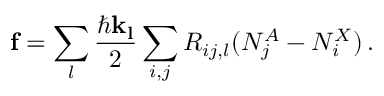<formula> <loc_0><loc_0><loc_500><loc_500>f = \sum _ { l } \frac { \hbar { k } _ { l } } { 2 } \sum _ { i , j } R _ { i j , l } ( N _ { j } ^ { A } - N _ { i } ^ { X } ) \, .</formula> 